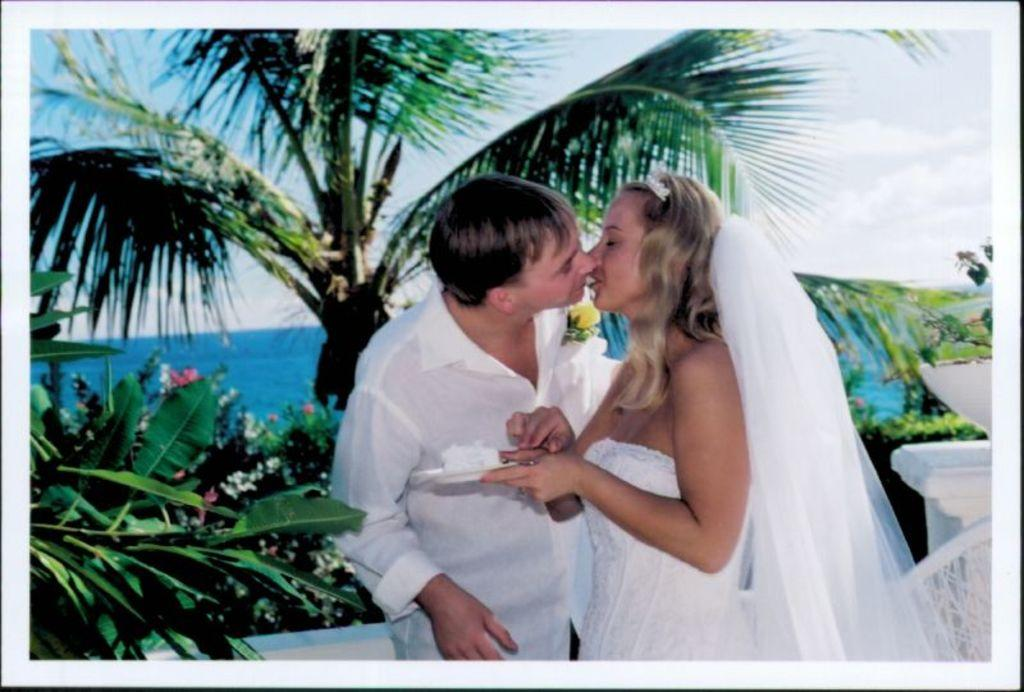What is happening between the two people in the image? The couple is kissing in the image. What type of natural environment is visible in the image? There are trees and water visible in the image. What type of scissors can be seen being used by the couple in the image? There are no scissors present in the image. What type of bed is visible in the image? There is no bed visible in the image. 